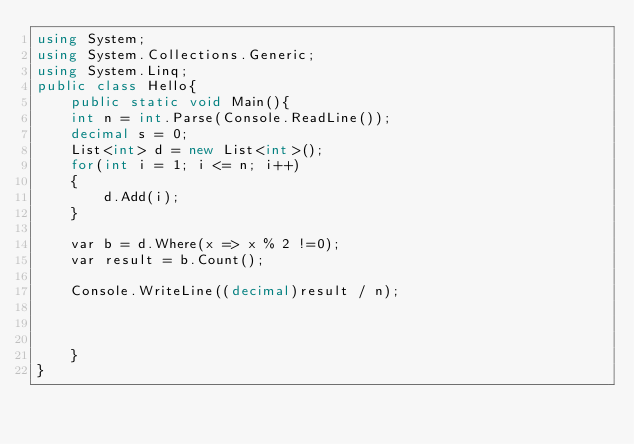<code> <loc_0><loc_0><loc_500><loc_500><_C#_>using System;
using System.Collections.Generic;
using System.Linq;
public class Hello{
    public static void Main(){
    int n = int.Parse(Console.ReadLine());
    decimal s = 0;
    List<int> d = new List<int>();
    for(int i = 1; i <= n; i++)
    {
        d.Add(i);
    }

    var b = d.Where(x => x % 2 !=0);
    var result = b.Count();

    Console.WriteLine((decimal)result / n);
   
    
 
    }
}
</code> 